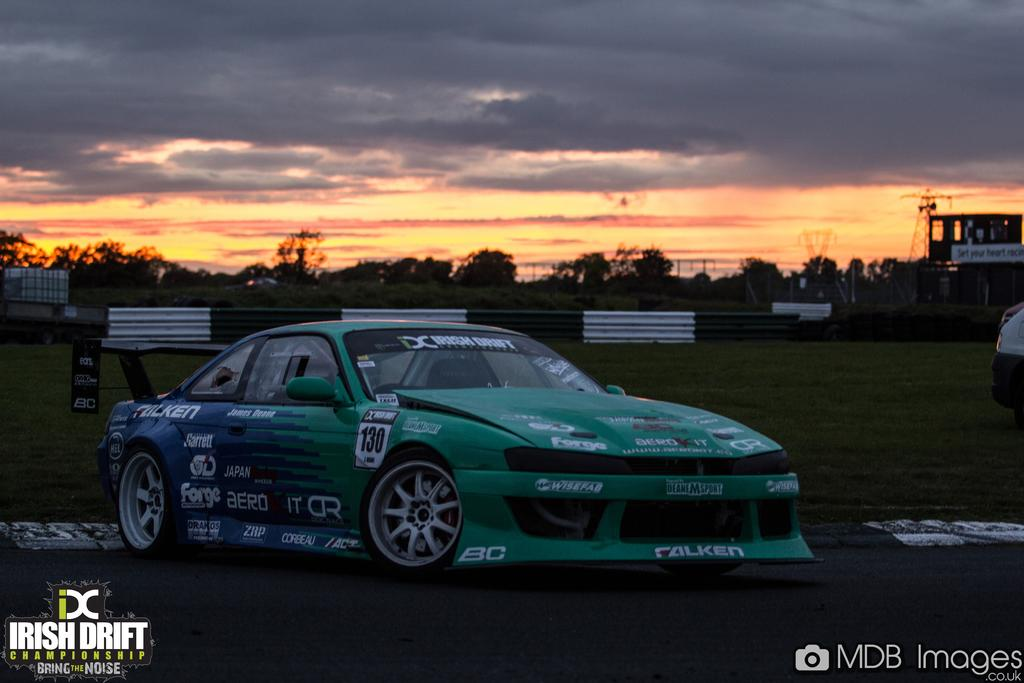What type of animal can be seen in the image? There is a cat in the image. What type of vegetation is present in the image? There is grass in the image. What type of structure is visible in the image? There is a building in the image. What other natural elements can be seen in the image? There are trees in the image. What part of the natural environment is visible in the image? The sky is visible in the image. What can be observed in the sky in the image? There are clouds in the image. What day of the week is the cat working in the office in the image? There is no office or indication of a specific day of the week in the image; it features a cat, grass, a building, trees, the sky, and clouds. 